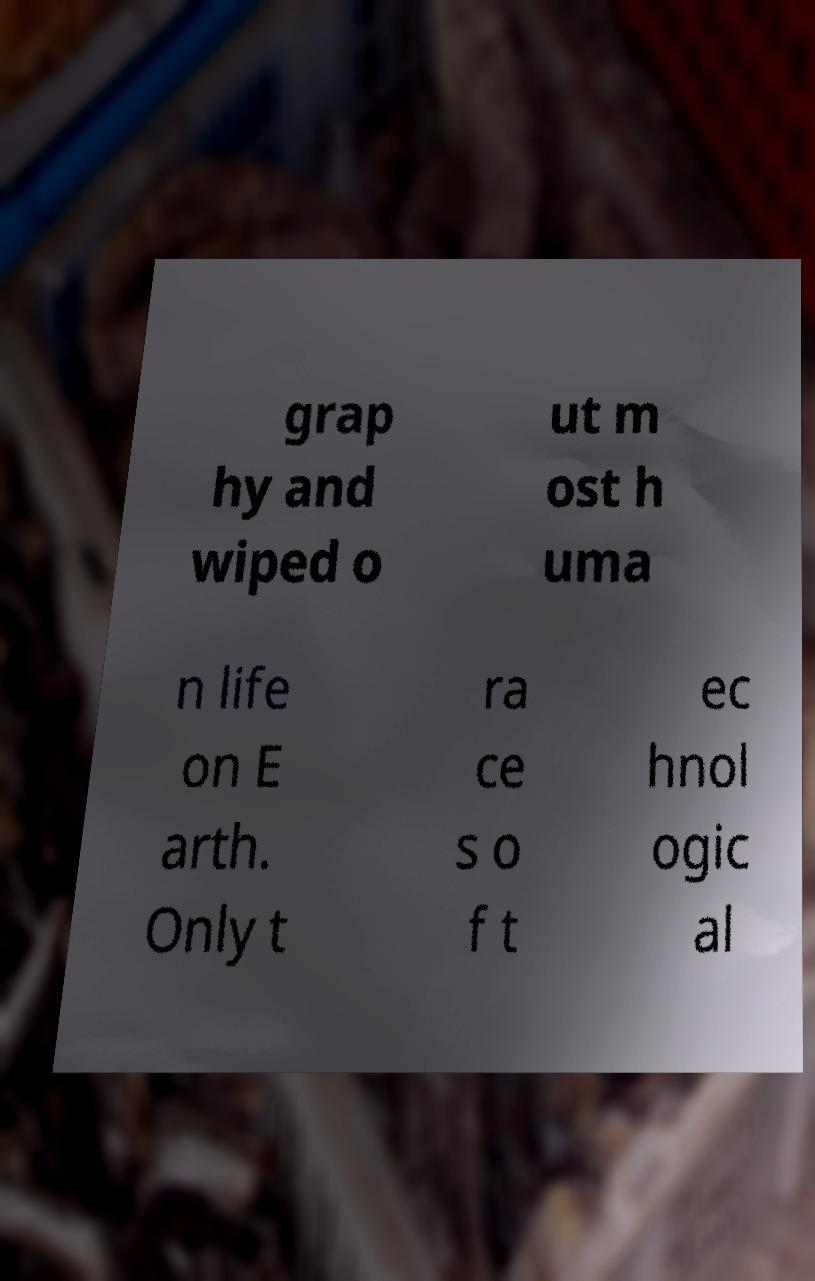For documentation purposes, I need the text within this image transcribed. Could you provide that? grap hy and wiped o ut m ost h uma n life on E arth. Only t ra ce s o f t ec hnol ogic al 